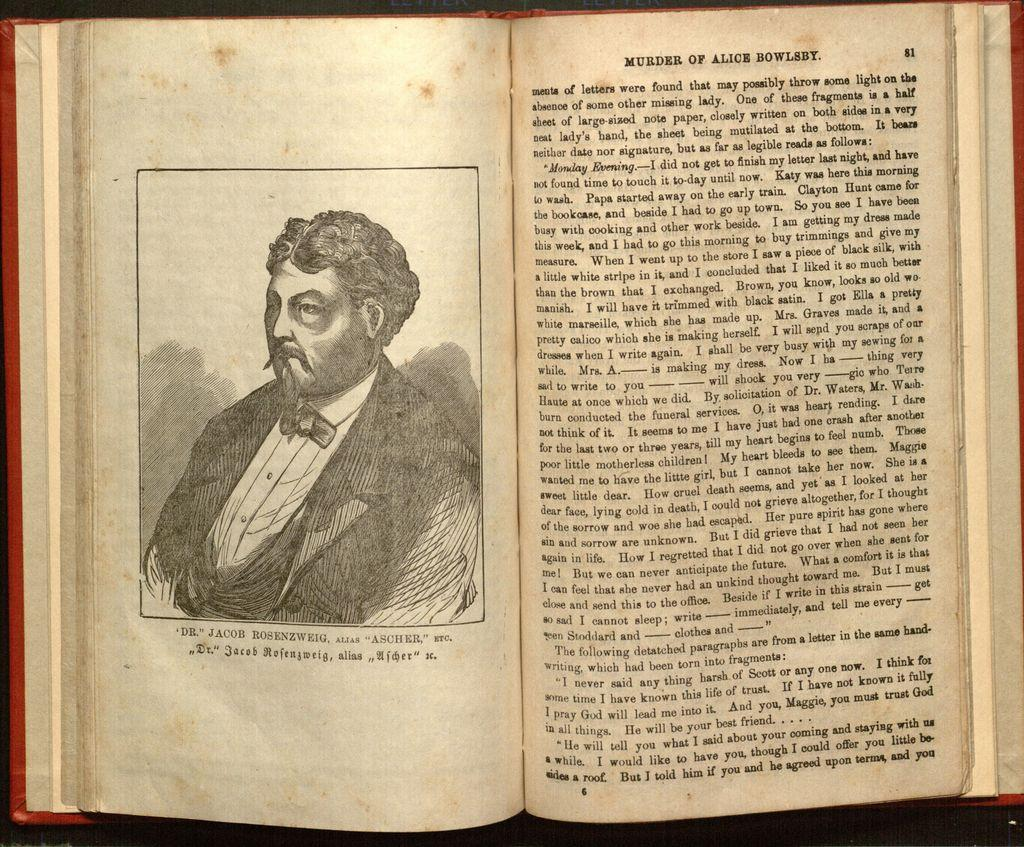Provide a one-sentence caption for the provided image. A vintage book titled Murder of Alice Bowles opened to a middle page spread. 